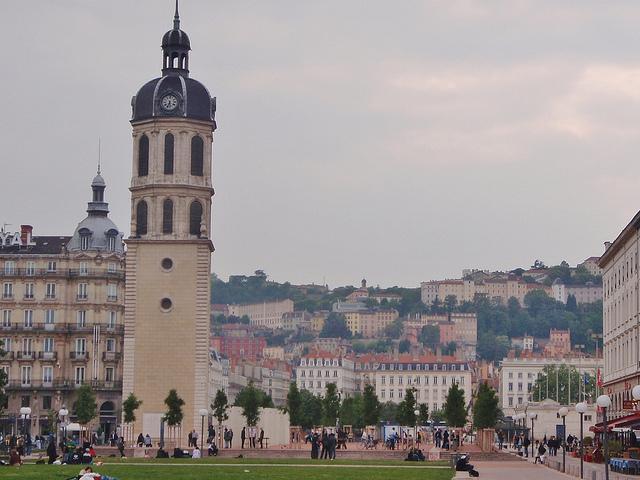How many clocks are here?
Give a very brief answer. 1. How many clock faces are shown?
Give a very brief answer. 1. How many black and white dogs are in the image?
Give a very brief answer. 0. 